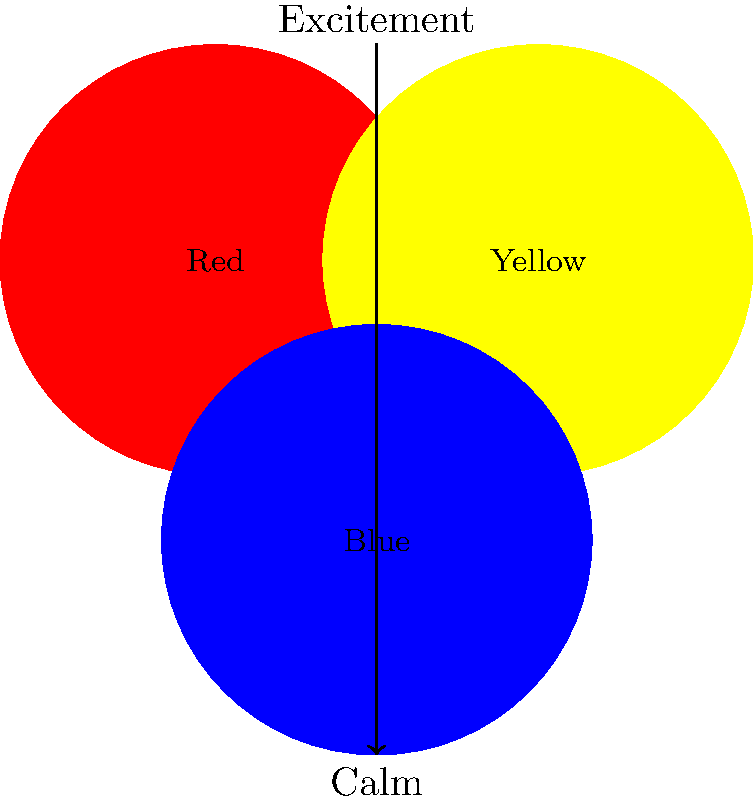In logo design, which color combination would be most appropriate to evoke a sense of energy and enthusiasm while maintaining a professional appearance? To answer this question, we need to consider the psychological effects of colors and their combinations:

1. Red: Associated with energy, excitement, and passion.
2. Yellow: Represents optimism, clarity, and warmth.
3. Blue: Conveys trust, professionalism, and stability.

Step 1: Analyze the emotional response needed
- We want to evoke energy and enthusiasm, which aligns with red and yellow.
- We also need to maintain a professional appearance, which is associated with blue.

Step 2: Consider color theory principles
- Complementary colors (opposite on the color wheel) create high contrast and energy.
- Analogous colors (adjacent on the color wheel) create harmony.

Step 3: Combine colors for the desired effect
- Red and yellow together create a high-energy combination.
- Adding blue to the mix balances the excitement with professionalism.

Step 4: Determine the most effective combination
- A combination of red and blue (with yellow as an accent) would be most appropriate.
- This combination maintains energy (red) while ensuring a professional appearance (blue).
- Yellow can be used as an accent to add warmth and optimism without overpowering the professional tone.

Therefore, the most appropriate color combination for evoking energy and enthusiasm while maintaining a professional appearance in logo design would be red and blue, with yellow as an accent color.
Answer: Red and blue, with yellow accent 